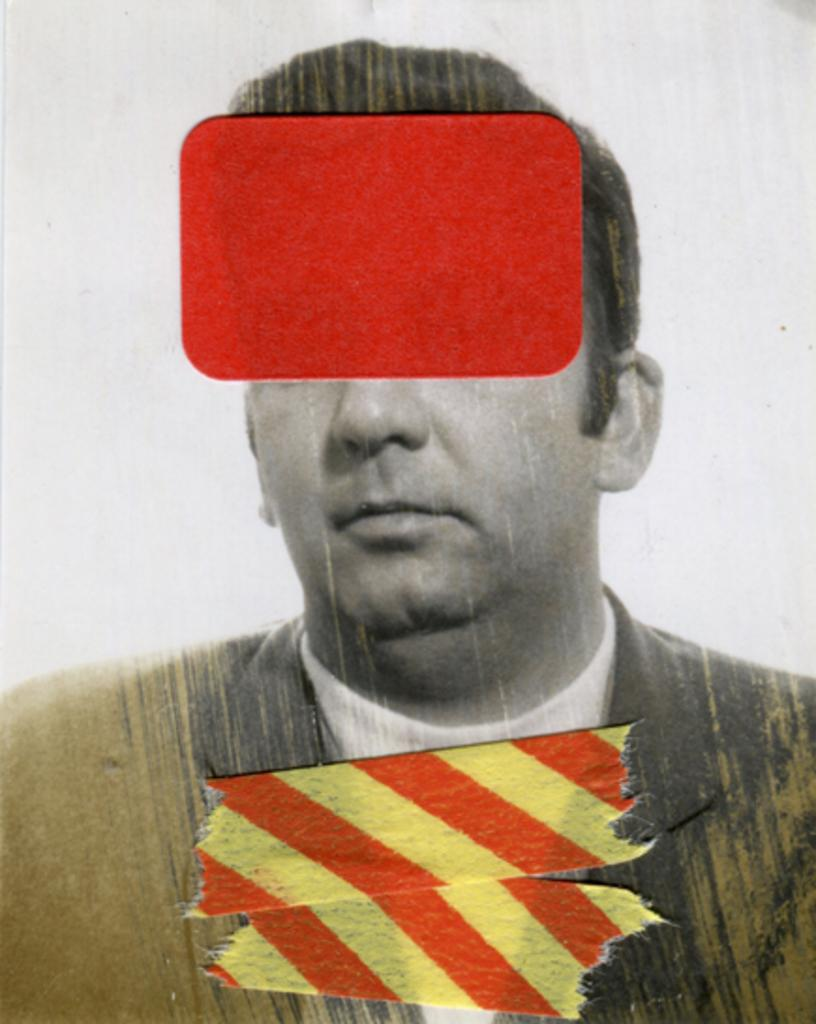What is the main subject of the image? There is a picture of a person in the image. Are there any additional elements on the picture? Yes, there are stickers on the picture. What color is the background of the image? The background of the image is white. What type of coat is the person wearing in the image? There is no coat visible in the image, as it only shows a picture of a person with stickers on it. Who created the stickers on the picture? The facts provided do not give any information about the creator of the stickers, so we cannot determine who made them. 